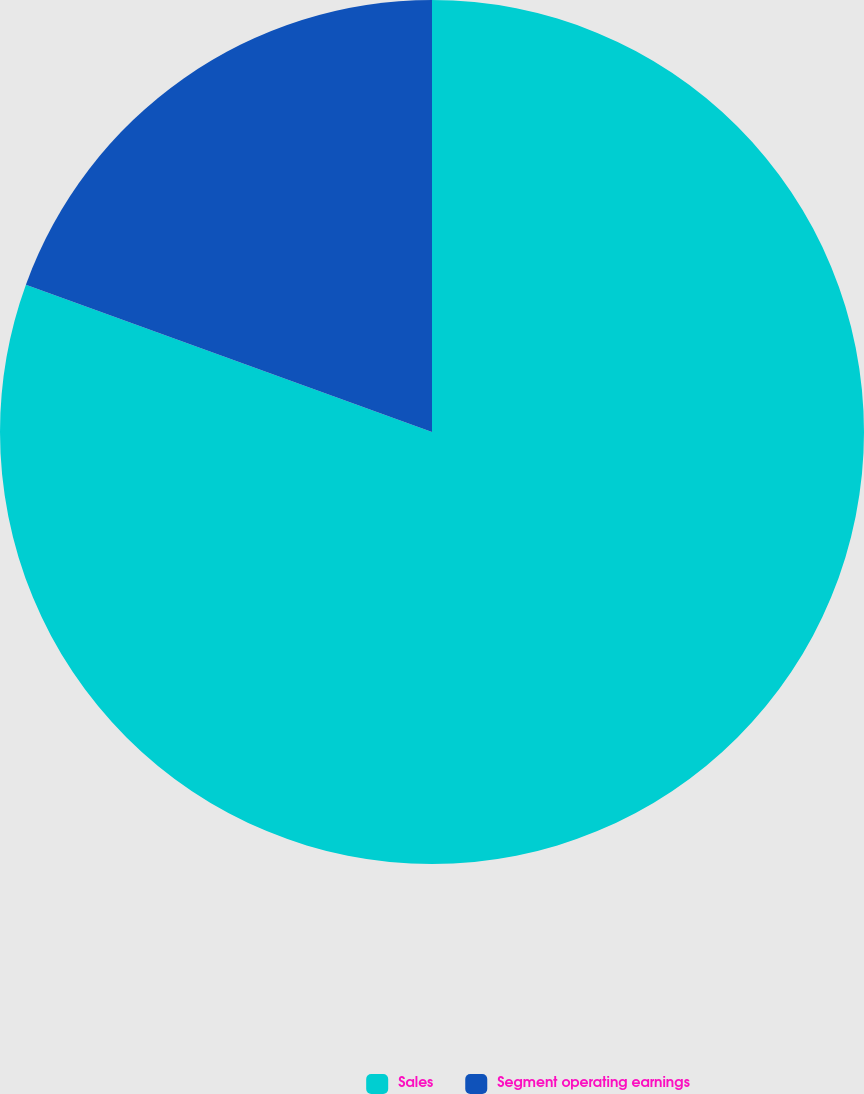Convert chart to OTSL. <chart><loc_0><loc_0><loc_500><loc_500><pie_chart><fcel>Sales<fcel>Segment operating earnings<nl><fcel>80.54%<fcel>19.46%<nl></chart> 